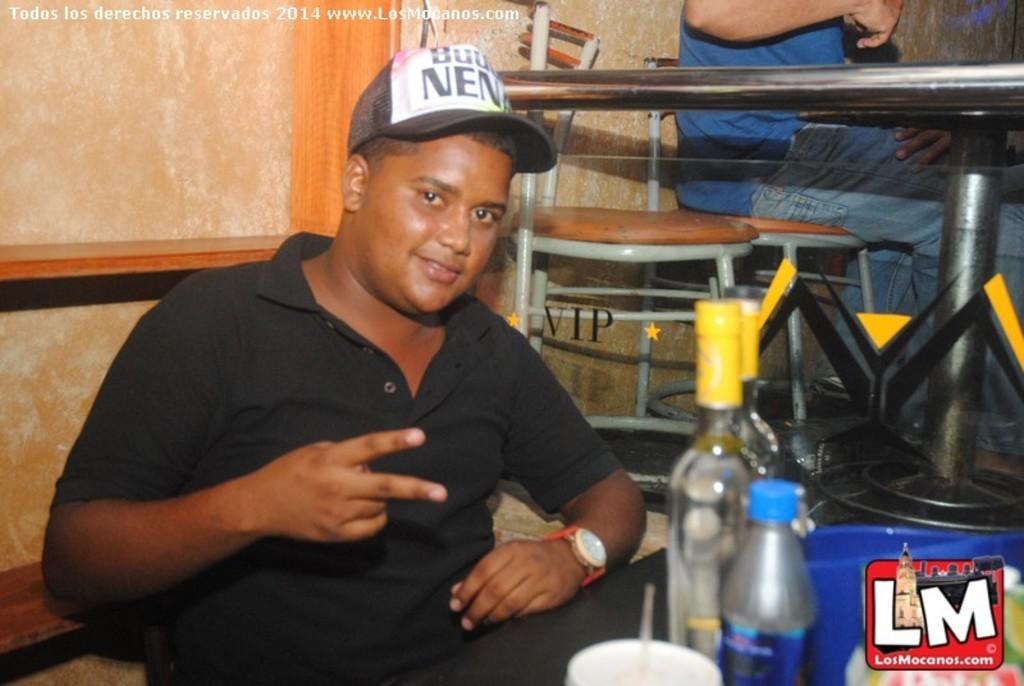What is the person in the image doing? There is a person sitting in the image, but their activity is not specified. What type of beverages are on the table? There are wine bottles and a juice bottle on the table. What else is on the table besides the bottles? There is a cup on the table. Can you see a squirrel drinking from the hose on the route in the image? There is no squirrel, hose, or route present in the image. 